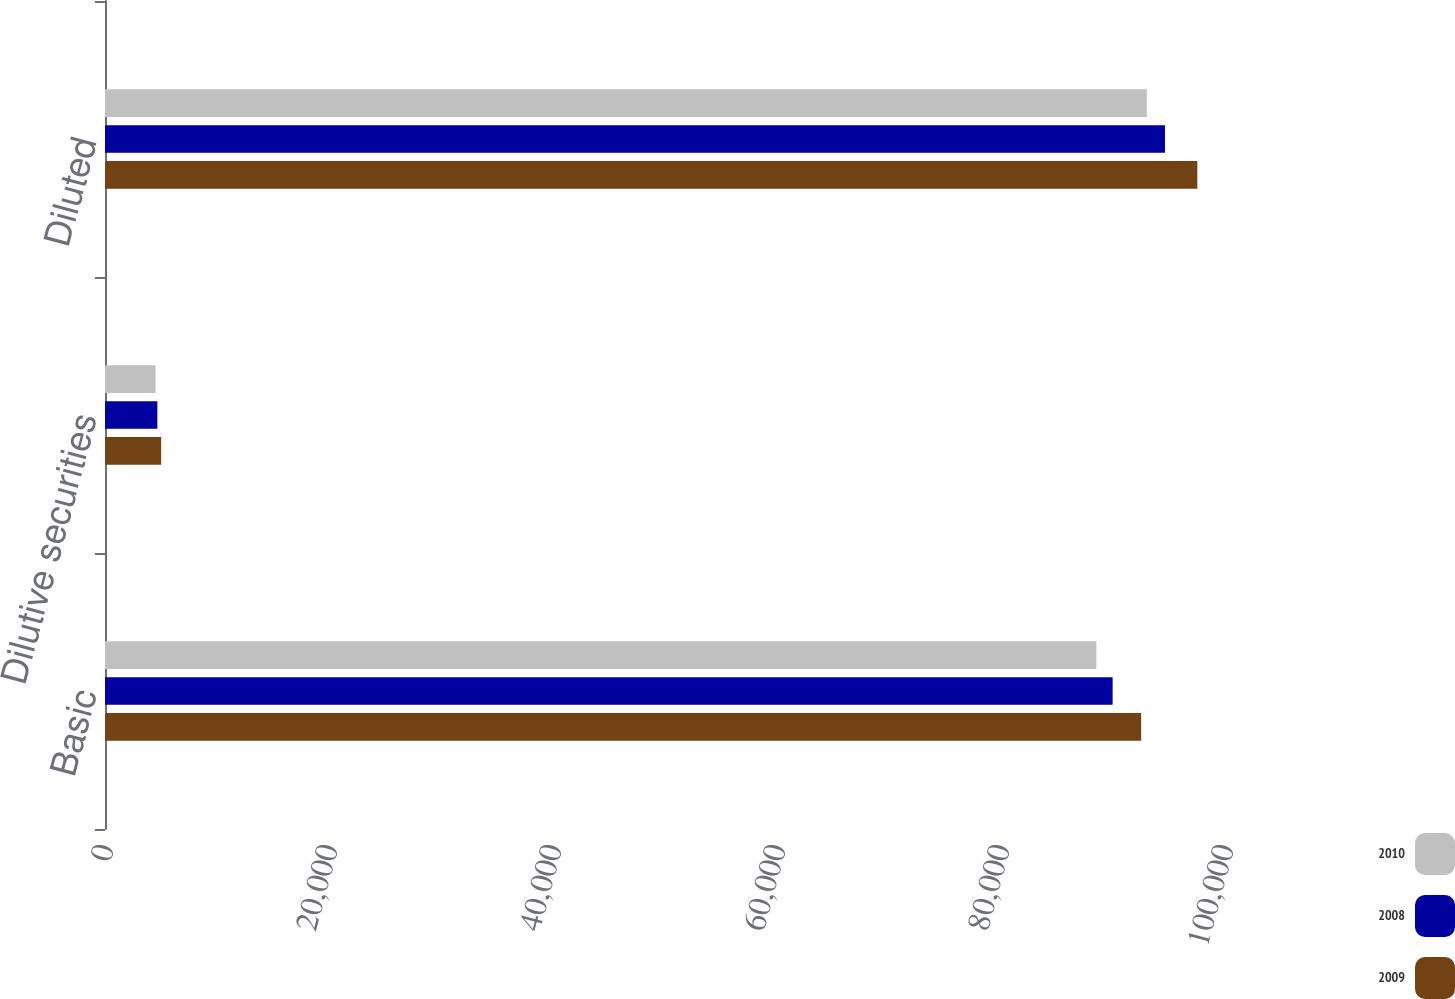Convert chart to OTSL. <chart><loc_0><loc_0><loc_500><loc_500><stacked_bar_chart><ecel><fcel>Basic<fcel>Dilutive securities<fcel>Diluted<nl><fcel>2010<fcel>88514<fcel>4507<fcel>93021<nl><fcel>2008<fcel>89967<fcel>4676<fcel>94643<nl><fcel>2009<fcel>92515<fcel>5015<fcel>97530<nl></chart> 